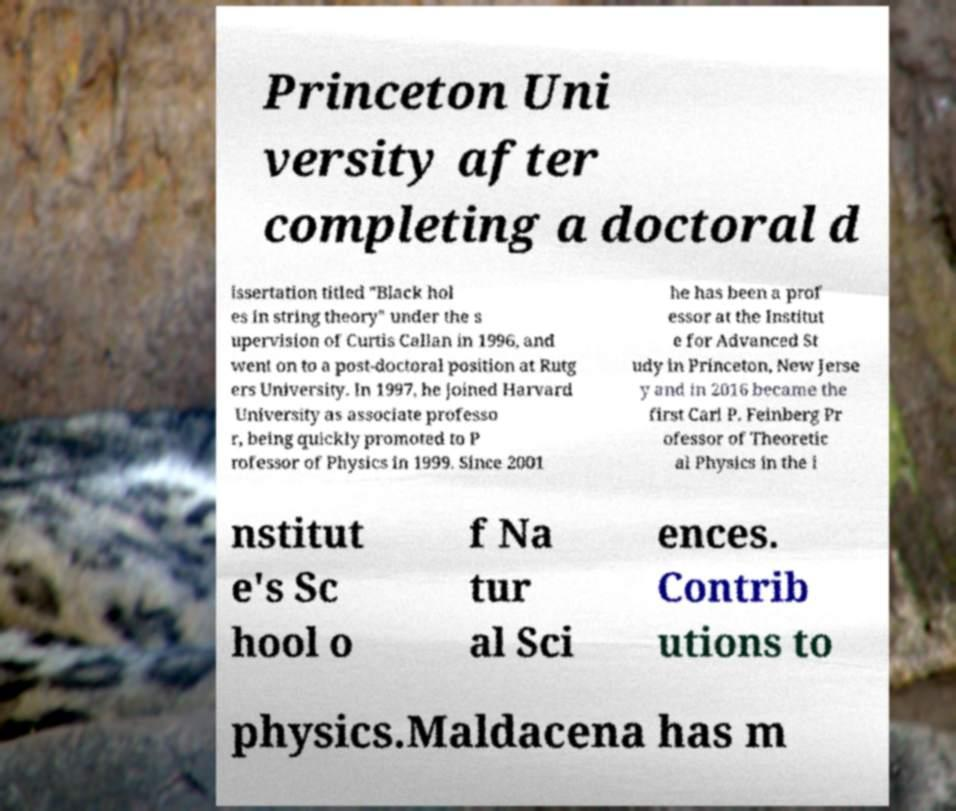Can you accurately transcribe the text from the provided image for me? Princeton Uni versity after completing a doctoral d issertation titled "Black hol es in string theory" under the s upervision of Curtis Callan in 1996, and went on to a post-doctoral position at Rutg ers University. In 1997, he joined Harvard University as associate professo r, being quickly promoted to P rofessor of Physics in 1999. Since 2001 he has been a prof essor at the Institut e for Advanced St udy in Princeton, New Jerse y and in 2016 became the first Carl P. Feinberg Pr ofessor of Theoretic al Physics in the i nstitut e's Sc hool o f Na tur al Sci ences. Contrib utions to physics.Maldacena has m 